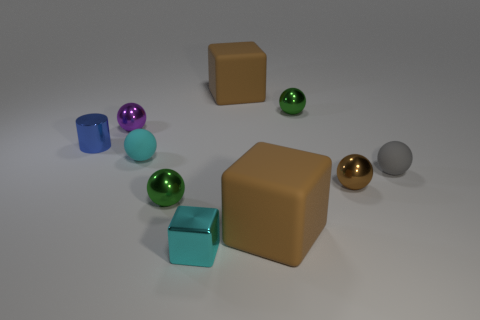Subtract all tiny gray rubber balls. How many balls are left? 5 Subtract all cyan spheres. How many spheres are left? 5 Subtract all cyan cylinders. How many brown cubes are left? 2 Add 8 purple things. How many purple things exist? 9 Subtract 0 purple cylinders. How many objects are left? 10 Subtract all cylinders. How many objects are left? 9 Subtract 5 spheres. How many spheres are left? 1 Subtract all blue blocks. Subtract all purple cylinders. How many blocks are left? 3 Subtract all tiny objects. Subtract all big yellow shiny things. How many objects are left? 2 Add 1 small spheres. How many small spheres are left? 7 